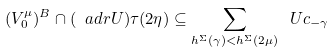Convert formula to latex. <formula><loc_0><loc_0><loc_500><loc_500>( V _ { 0 } ^ { \mu } ) ^ { B } \cap ( \ a d r U ) \tau ( 2 \eta ) \subseteq \sum _ { h ^ { \Sigma } ( \gamma ) < h ^ { \Sigma } ( 2 \mu ) } \ U c _ { - \gamma }</formula> 